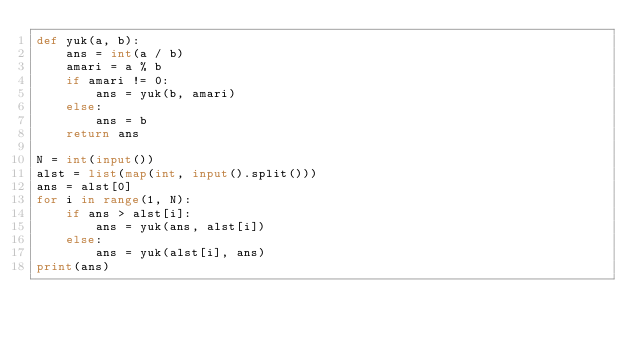Convert code to text. <code><loc_0><loc_0><loc_500><loc_500><_Python_>def yuk(a, b):
    ans = int(a / b)
    amari = a % b
    if amari != 0:
        ans = yuk(b, amari)
    else:
        ans = b
    return ans

N = int(input())
alst = list(map(int, input().split()))
ans = alst[0]
for i in range(1, N):
    if ans > alst[i]:
        ans = yuk(ans, alst[i])
    else:
        ans = yuk(alst[i], ans)
print(ans)</code> 